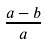<formula> <loc_0><loc_0><loc_500><loc_500>\frac { a - b } { a }</formula> 